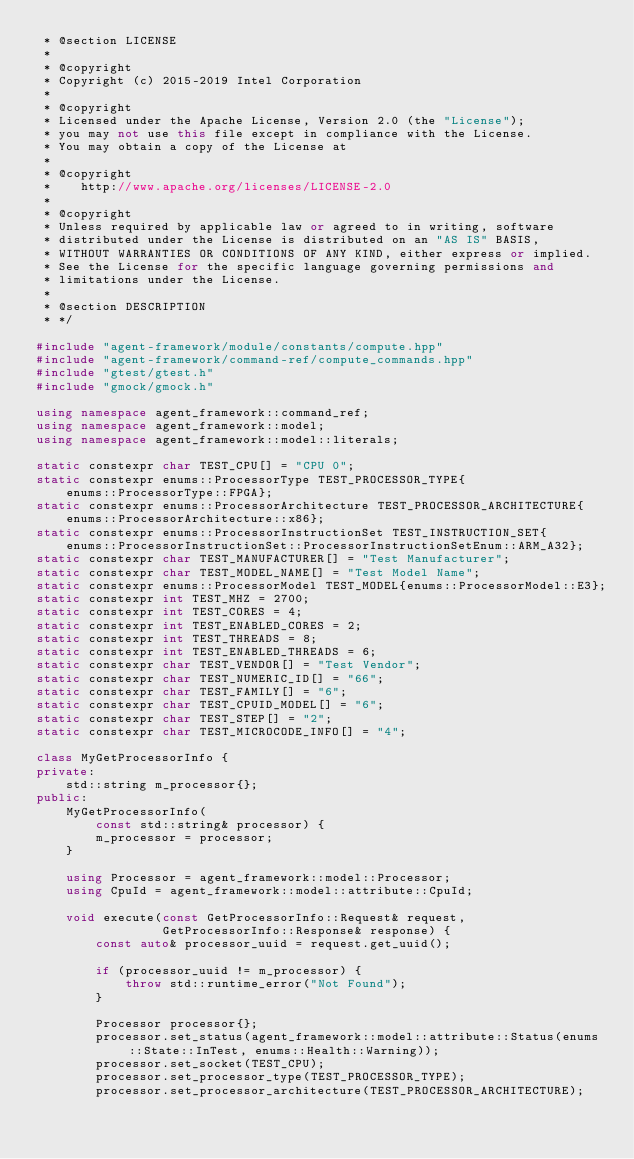<code> <loc_0><loc_0><loc_500><loc_500><_C++_> * @section LICENSE
 *
 * @copyright
 * Copyright (c) 2015-2019 Intel Corporation
 *
 * @copyright
 * Licensed under the Apache License, Version 2.0 (the "License");
 * you may not use this file except in compliance with the License.
 * You may obtain a copy of the License at
 *
 * @copyright
 *    http://www.apache.org/licenses/LICENSE-2.0
 *
 * @copyright
 * Unless required by applicable law or agreed to in writing, software
 * distributed under the License is distributed on an "AS IS" BASIS,
 * WITHOUT WARRANTIES OR CONDITIONS OF ANY KIND, either express or implied.
 * See the License for the specific language governing permissions and
 * limitations under the License.
 *
 * @section DESCRIPTION
 * */

#include "agent-framework/module/constants/compute.hpp"
#include "agent-framework/command-ref/compute_commands.hpp"
#include "gtest/gtest.h"
#include "gmock/gmock.h"

using namespace agent_framework::command_ref;
using namespace agent_framework::model;
using namespace agent_framework::model::literals;

static constexpr char TEST_CPU[] = "CPU 0";
static constexpr enums::ProcessorType TEST_PROCESSOR_TYPE{
    enums::ProcessorType::FPGA};
static constexpr enums::ProcessorArchitecture TEST_PROCESSOR_ARCHITECTURE{
    enums::ProcessorArchitecture::x86};
static constexpr enums::ProcessorInstructionSet TEST_INSTRUCTION_SET{
    enums::ProcessorInstructionSet::ProcessorInstructionSetEnum::ARM_A32};
static constexpr char TEST_MANUFACTURER[] = "Test Manufacturer";
static constexpr char TEST_MODEL_NAME[] = "Test Model Name";
static constexpr enums::ProcessorModel TEST_MODEL{enums::ProcessorModel::E3};
static constexpr int TEST_MHZ = 2700;
static constexpr int TEST_CORES = 4;
static constexpr int TEST_ENABLED_CORES = 2;
static constexpr int TEST_THREADS = 8;
static constexpr int TEST_ENABLED_THREADS = 6;
static constexpr char TEST_VENDOR[] = "Test Vendor";
static constexpr char TEST_NUMERIC_ID[] = "66";
static constexpr char TEST_FAMILY[] = "6";
static constexpr char TEST_CPUID_MODEL[] = "6";
static constexpr char TEST_STEP[] = "2";
static constexpr char TEST_MICROCODE_INFO[] = "4";

class MyGetProcessorInfo {
private:
    std::string m_processor{};
public:
    MyGetProcessorInfo(
        const std::string& processor) {
        m_processor = processor;
    }

    using Processor = agent_framework::model::Processor;
    using CpuId = agent_framework::model::attribute::CpuId;

    void execute(const GetProcessorInfo::Request& request,
                 GetProcessorInfo::Response& response) {
        const auto& processor_uuid = request.get_uuid();

        if (processor_uuid != m_processor) {
            throw std::runtime_error("Not Found");
        }

        Processor processor{};
        processor.set_status(agent_framework::model::attribute::Status(enums::State::InTest, enums::Health::Warning));
        processor.set_socket(TEST_CPU);
        processor.set_processor_type(TEST_PROCESSOR_TYPE);
        processor.set_processor_architecture(TEST_PROCESSOR_ARCHITECTURE);</code> 